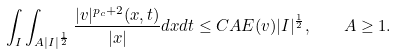Convert formula to latex. <formula><loc_0><loc_0><loc_500><loc_500>\int _ { I } \int _ { A | I | ^ { \frac { 1 } { 2 } } } \frac { | v | ^ { p _ { c } + 2 } ( x , t ) } { | x | } d x d t \leq C A E ( v ) | I | ^ { \frac { 1 } { 2 } } , \quad A \geq 1 .</formula> 